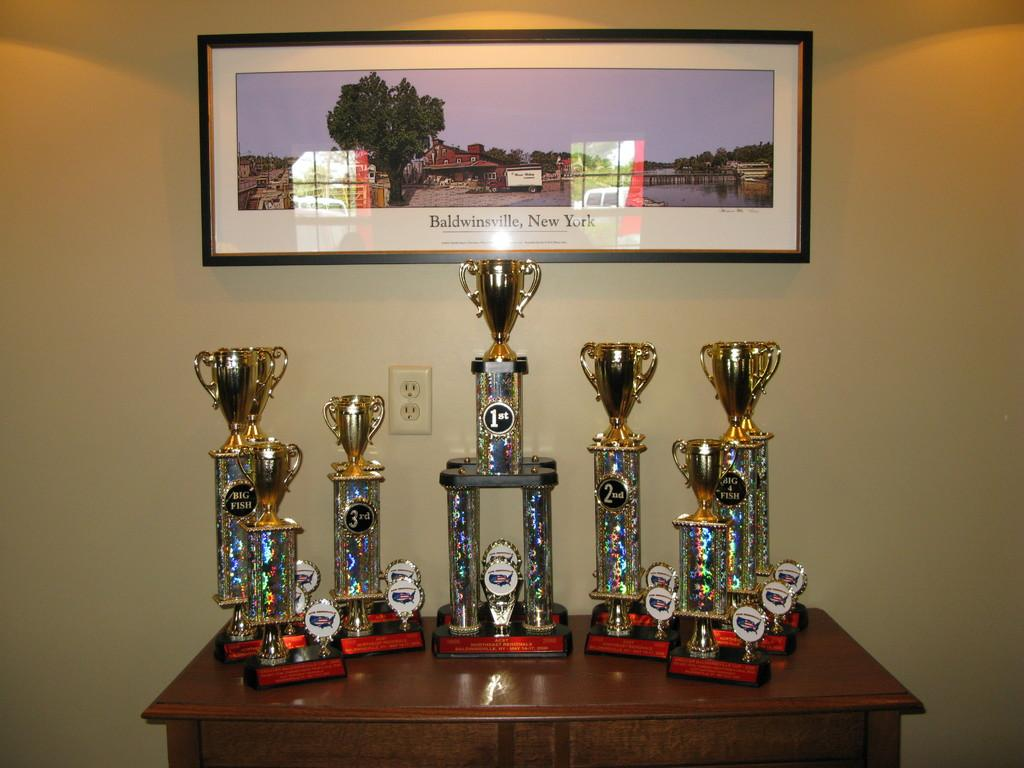<image>
Describe the image concisely. A framed picture that says Baldwinsville, New York has several trophies displayed underneath it. 